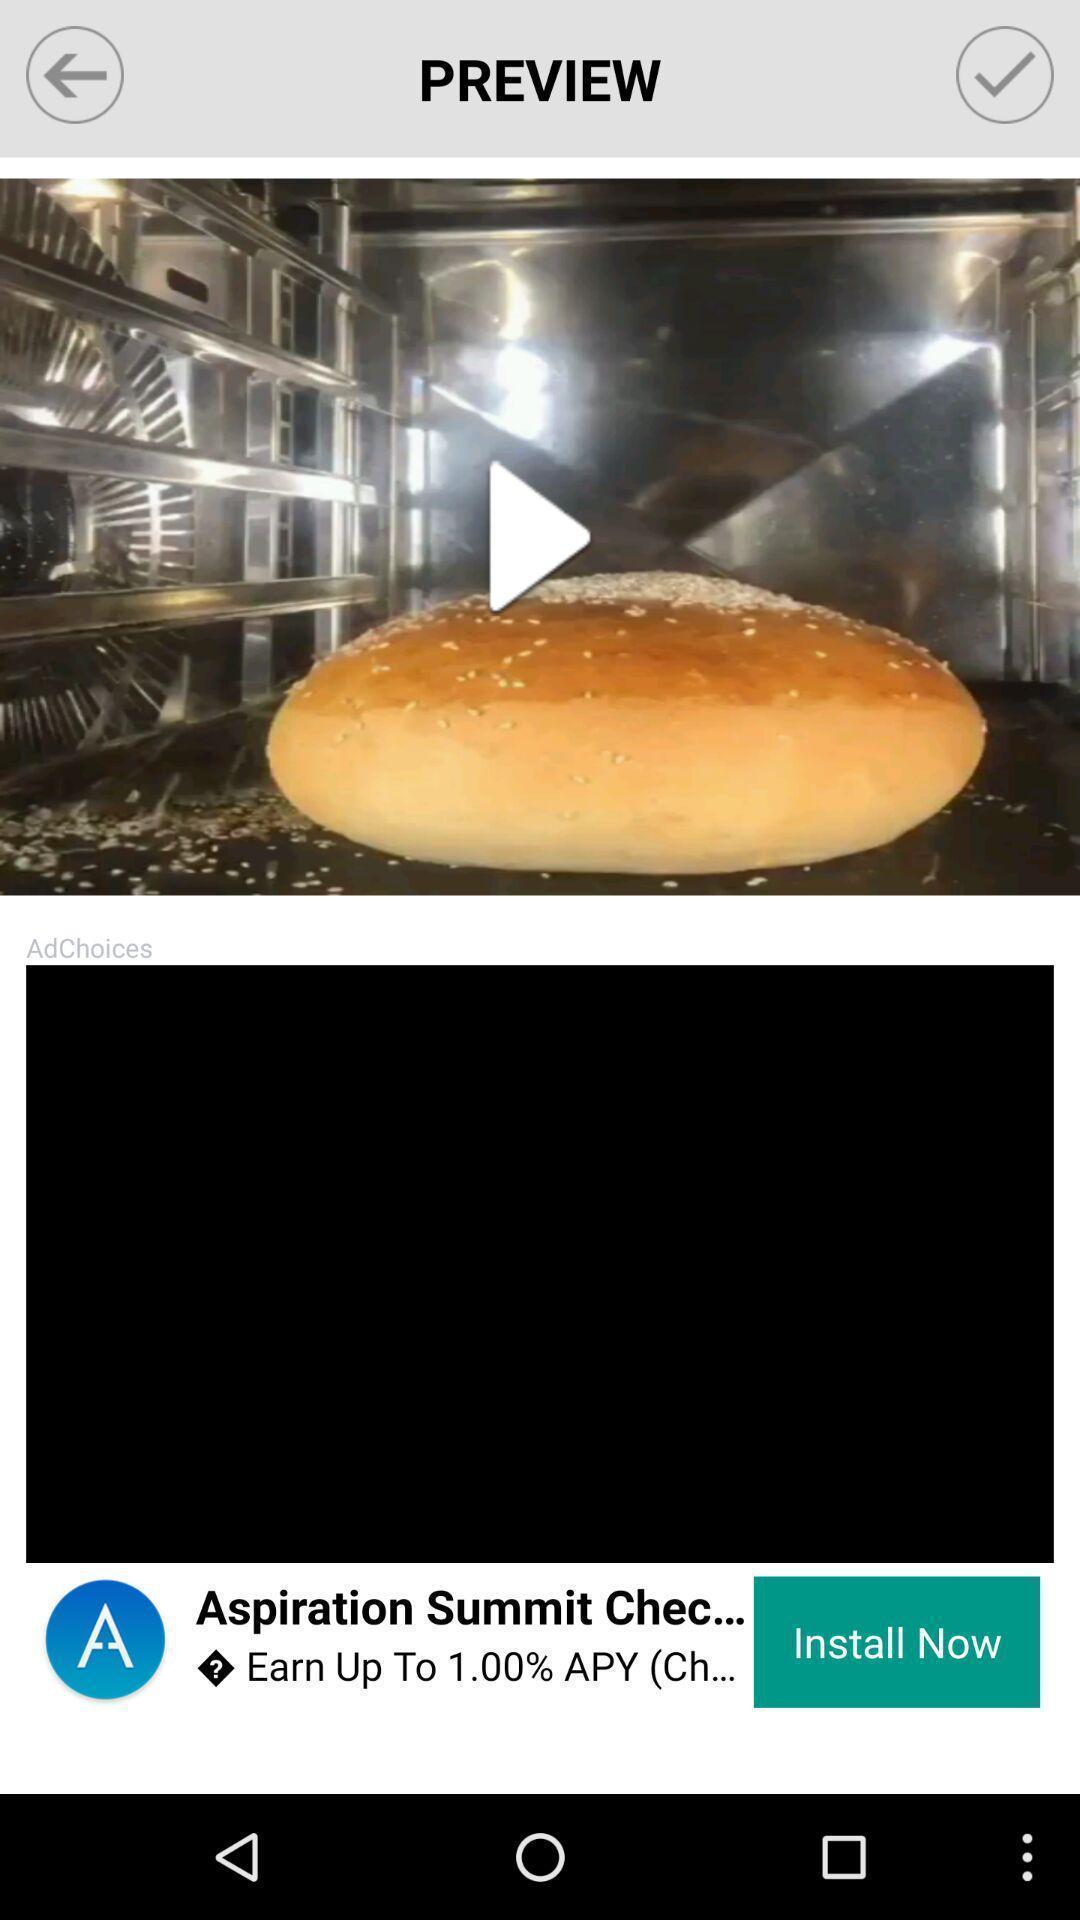Provide a detailed account of this screenshot. Video about a food item is displaying. 